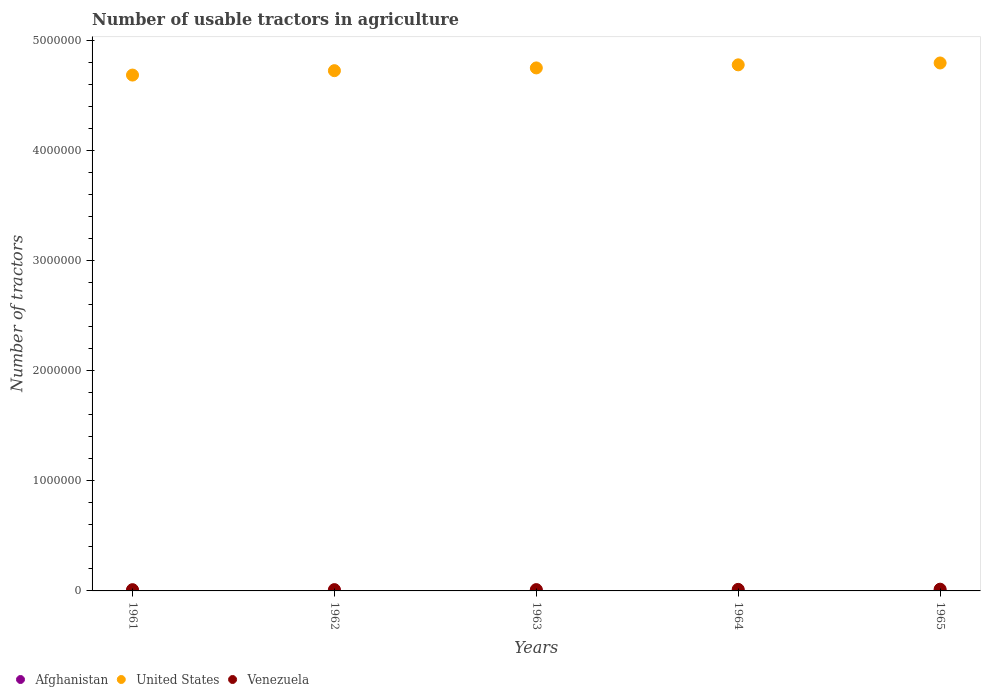How many different coloured dotlines are there?
Give a very brief answer. 3. Is the number of dotlines equal to the number of legend labels?
Give a very brief answer. Yes. What is the number of usable tractors in agriculture in Venezuela in 1965?
Give a very brief answer. 1.59e+04. Across all years, what is the maximum number of usable tractors in agriculture in Afghanistan?
Your answer should be compact. 300. Across all years, what is the minimum number of usable tractors in agriculture in Afghanistan?
Make the answer very short. 120. In which year was the number of usable tractors in agriculture in Afghanistan maximum?
Provide a short and direct response. 1965. In which year was the number of usable tractors in agriculture in Afghanistan minimum?
Ensure brevity in your answer.  1961. What is the total number of usable tractors in agriculture in United States in the graph?
Your response must be concise. 2.38e+07. What is the difference between the number of usable tractors in agriculture in Venezuela in 1962 and that in 1964?
Your answer should be compact. -2280. What is the difference between the number of usable tractors in agriculture in United States in 1965 and the number of usable tractors in agriculture in Afghanistan in 1963?
Ensure brevity in your answer.  4.80e+06. What is the average number of usable tractors in agriculture in United States per year?
Give a very brief answer. 4.75e+06. In the year 1965, what is the difference between the number of usable tractors in agriculture in Venezuela and number of usable tractors in agriculture in United States?
Provide a succinct answer. -4.78e+06. What is the ratio of the number of usable tractors in agriculture in Venezuela in 1962 to that in 1963?
Offer a very short reply. 0.99. Is the number of usable tractors in agriculture in Afghanistan in 1962 less than that in 1964?
Offer a terse response. Yes. What is the difference between the highest and the second highest number of usable tractors in agriculture in Venezuela?
Keep it short and to the point. 1720. What is the difference between the highest and the lowest number of usable tractors in agriculture in Venezuela?
Ensure brevity in your answer.  4500. In how many years, is the number of usable tractors in agriculture in Afghanistan greater than the average number of usable tractors in agriculture in Afghanistan taken over all years?
Keep it short and to the point. 3. Is it the case that in every year, the sum of the number of usable tractors in agriculture in Afghanistan and number of usable tractors in agriculture in Venezuela  is greater than the number of usable tractors in agriculture in United States?
Your answer should be compact. No. Is the number of usable tractors in agriculture in Afghanistan strictly greater than the number of usable tractors in agriculture in Venezuela over the years?
Offer a very short reply. No. How many years are there in the graph?
Make the answer very short. 5. Are the values on the major ticks of Y-axis written in scientific E-notation?
Offer a terse response. No. How are the legend labels stacked?
Offer a very short reply. Horizontal. What is the title of the graph?
Provide a short and direct response. Number of usable tractors in agriculture. What is the label or title of the Y-axis?
Your answer should be compact. Number of tractors. What is the Number of tractors of Afghanistan in 1961?
Keep it short and to the point. 120. What is the Number of tractors in United States in 1961?
Offer a terse response. 4.69e+06. What is the Number of tractors of Venezuela in 1961?
Ensure brevity in your answer.  1.14e+04. What is the Number of tractors in Afghanistan in 1962?
Your answer should be compact. 150. What is the Number of tractors of United States in 1962?
Make the answer very short. 4.73e+06. What is the Number of tractors of Venezuela in 1962?
Your response must be concise. 1.19e+04. What is the Number of tractors in Afghanistan in 1963?
Provide a short and direct response. 200. What is the Number of tractors in United States in 1963?
Offer a very short reply. 4.76e+06. What is the Number of tractors in Venezuela in 1963?
Provide a succinct answer. 1.20e+04. What is the Number of tractors of United States in 1964?
Your answer should be very brief. 4.78e+06. What is the Number of tractors in Venezuela in 1964?
Your response must be concise. 1.42e+04. What is the Number of tractors in Afghanistan in 1965?
Provide a succinct answer. 300. What is the Number of tractors in United States in 1965?
Provide a short and direct response. 4.80e+06. What is the Number of tractors of Venezuela in 1965?
Give a very brief answer. 1.59e+04. Across all years, what is the maximum Number of tractors in Afghanistan?
Give a very brief answer. 300. Across all years, what is the maximum Number of tractors of United States?
Ensure brevity in your answer.  4.80e+06. Across all years, what is the maximum Number of tractors of Venezuela?
Your response must be concise. 1.59e+04. Across all years, what is the minimum Number of tractors in Afghanistan?
Offer a terse response. 120. Across all years, what is the minimum Number of tractors of United States?
Make the answer very short. 4.69e+06. Across all years, what is the minimum Number of tractors in Venezuela?
Keep it short and to the point. 1.14e+04. What is the total Number of tractors in Afghanistan in the graph?
Offer a terse response. 970. What is the total Number of tractors of United States in the graph?
Ensure brevity in your answer.  2.38e+07. What is the total Number of tractors in Venezuela in the graph?
Your answer should be very brief. 6.54e+04. What is the difference between the Number of tractors of Venezuela in 1961 and that in 1962?
Provide a succinct answer. -500. What is the difference between the Number of tractors in Afghanistan in 1961 and that in 1963?
Keep it short and to the point. -80. What is the difference between the Number of tractors in United States in 1961 and that in 1963?
Keep it short and to the point. -6.50e+04. What is the difference between the Number of tractors in Venezuela in 1961 and that in 1963?
Keep it short and to the point. -650. What is the difference between the Number of tractors in Afghanistan in 1961 and that in 1964?
Your answer should be compact. -80. What is the difference between the Number of tractors in United States in 1961 and that in 1964?
Give a very brief answer. -9.30e+04. What is the difference between the Number of tractors of Venezuela in 1961 and that in 1964?
Your answer should be compact. -2780. What is the difference between the Number of tractors of Afghanistan in 1961 and that in 1965?
Your answer should be compact. -180. What is the difference between the Number of tractors of Venezuela in 1961 and that in 1965?
Your answer should be compact. -4500. What is the difference between the Number of tractors of Afghanistan in 1962 and that in 1963?
Ensure brevity in your answer.  -50. What is the difference between the Number of tractors in United States in 1962 and that in 1963?
Ensure brevity in your answer.  -2.50e+04. What is the difference between the Number of tractors of Venezuela in 1962 and that in 1963?
Provide a succinct answer. -150. What is the difference between the Number of tractors of Afghanistan in 1962 and that in 1964?
Make the answer very short. -50. What is the difference between the Number of tractors of United States in 1962 and that in 1964?
Provide a short and direct response. -5.30e+04. What is the difference between the Number of tractors in Venezuela in 1962 and that in 1964?
Your response must be concise. -2280. What is the difference between the Number of tractors of Afghanistan in 1962 and that in 1965?
Your answer should be compact. -150. What is the difference between the Number of tractors in United States in 1962 and that in 1965?
Provide a succinct answer. -7.00e+04. What is the difference between the Number of tractors of Venezuela in 1962 and that in 1965?
Offer a very short reply. -4000. What is the difference between the Number of tractors of United States in 1963 and that in 1964?
Your answer should be very brief. -2.80e+04. What is the difference between the Number of tractors in Venezuela in 1963 and that in 1964?
Provide a short and direct response. -2130. What is the difference between the Number of tractors in Afghanistan in 1963 and that in 1965?
Your answer should be very brief. -100. What is the difference between the Number of tractors of United States in 1963 and that in 1965?
Give a very brief answer. -4.50e+04. What is the difference between the Number of tractors in Venezuela in 1963 and that in 1965?
Provide a succinct answer. -3850. What is the difference between the Number of tractors of Afghanistan in 1964 and that in 1965?
Keep it short and to the point. -100. What is the difference between the Number of tractors in United States in 1964 and that in 1965?
Your answer should be very brief. -1.70e+04. What is the difference between the Number of tractors of Venezuela in 1964 and that in 1965?
Make the answer very short. -1720. What is the difference between the Number of tractors in Afghanistan in 1961 and the Number of tractors in United States in 1962?
Offer a very short reply. -4.73e+06. What is the difference between the Number of tractors in Afghanistan in 1961 and the Number of tractors in Venezuela in 1962?
Give a very brief answer. -1.18e+04. What is the difference between the Number of tractors in United States in 1961 and the Number of tractors in Venezuela in 1962?
Offer a very short reply. 4.68e+06. What is the difference between the Number of tractors of Afghanistan in 1961 and the Number of tractors of United States in 1963?
Provide a short and direct response. -4.75e+06. What is the difference between the Number of tractors in Afghanistan in 1961 and the Number of tractors in Venezuela in 1963?
Your answer should be very brief. -1.19e+04. What is the difference between the Number of tractors of United States in 1961 and the Number of tractors of Venezuela in 1963?
Provide a short and direct response. 4.68e+06. What is the difference between the Number of tractors of Afghanistan in 1961 and the Number of tractors of United States in 1964?
Ensure brevity in your answer.  -4.78e+06. What is the difference between the Number of tractors in Afghanistan in 1961 and the Number of tractors in Venezuela in 1964?
Offer a very short reply. -1.41e+04. What is the difference between the Number of tractors of United States in 1961 and the Number of tractors of Venezuela in 1964?
Your answer should be very brief. 4.68e+06. What is the difference between the Number of tractors of Afghanistan in 1961 and the Number of tractors of United States in 1965?
Ensure brevity in your answer.  -4.80e+06. What is the difference between the Number of tractors in Afghanistan in 1961 and the Number of tractors in Venezuela in 1965?
Provide a succinct answer. -1.58e+04. What is the difference between the Number of tractors in United States in 1961 and the Number of tractors in Venezuela in 1965?
Keep it short and to the point. 4.67e+06. What is the difference between the Number of tractors in Afghanistan in 1962 and the Number of tractors in United States in 1963?
Your response must be concise. -4.75e+06. What is the difference between the Number of tractors in Afghanistan in 1962 and the Number of tractors in Venezuela in 1963?
Provide a short and direct response. -1.19e+04. What is the difference between the Number of tractors in United States in 1962 and the Number of tractors in Venezuela in 1963?
Ensure brevity in your answer.  4.72e+06. What is the difference between the Number of tractors in Afghanistan in 1962 and the Number of tractors in United States in 1964?
Keep it short and to the point. -4.78e+06. What is the difference between the Number of tractors in Afghanistan in 1962 and the Number of tractors in Venezuela in 1964?
Keep it short and to the point. -1.40e+04. What is the difference between the Number of tractors of United States in 1962 and the Number of tractors of Venezuela in 1964?
Offer a very short reply. 4.72e+06. What is the difference between the Number of tractors of Afghanistan in 1962 and the Number of tractors of United States in 1965?
Offer a very short reply. -4.80e+06. What is the difference between the Number of tractors in Afghanistan in 1962 and the Number of tractors in Venezuela in 1965?
Ensure brevity in your answer.  -1.58e+04. What is the difference between the Number of tractors of United States in 1962 and the Number of tractors of Venezuela in 1965?
Keep it short and to the point. 4.71e+06. What is the difference between the Number of tractors of Afghanistan in 1963 and the Number of tractors of United States in 1964?
Keep it short and to the point. -4.78e+06. What is the difference between the Number of tractors in Afghanistan in 1963 and the Number of tractors in Venezuela in 1964?
Keep it short and to the point. -1.40e+04. What is the difference between the Number of tractors of United States in 1963 and the Number of tractors of Venezuela in 1964?
Offer a terse response. 4.74e+06. What is the difference between the Number of tractors of Afghanistan in 1963 and the Number of tractors of United States in 1965?
Offer a very short reply. -4.80e+06. What is the difference between the Number of tractors of Afghanistan in 1963 and the Number of tractors of Venezuela in 1965?
Your answer should be compact. -1.57e+04. What is the difference between the Number of tractors in United States in 1963 and the Number of tractors in Venezuela in 1965?
Your answer should be compact. 4.74e+06. What is the difference between the Number of tractors in Afghanistan in 1964 and the Number of tractors in United States in 1965?
Offer a terse response. -4.80e+06. What is the difference between the Number of tractors in Afghanistan in 1964 and the Number of tractors in Venezuela in 1965?
Your answer should be very brief. -1.57e+04. What is the difference between the Number of tractors in United States in 1964 and the Number of tractors in Venezuela in 1965?
Your answer should be compact. 4.77e+06. What is the average Number of tractors in Afghanistan per year?
Provide a short and direct response. 194. What is the average Number of tractors of United States per year?
Keep it short and to the point. 4.75e+06. What is the average Number of tractors in Venezuela per year?
Provide a short and direct response. 1.31e+04. In the year 1961, what is the difference between the Number of tractors in Afghanistan and Number of tractors in United States?
Give a very brief answer. -4.69e+06. In the year 1961, what is the difference between the Number of tractors in Afghanistan and Number of tractors in Venezuela?
Your response must be concise. -1.13e+04. In the year 1961, what is the difference between the Number of tractors of United States and Number of tractors of Venezuela?
Your response must be concise. 4.68e+06. In the year 1962, what is the difference between the Number of tractors of Afghanistan and Number of tractors of United States?
Your answer should be very brief. -4.73e+06. In the year 1962, what is the difference between the Number of tractors in Afghanistan and Number of tractors in Venezuela?
Provide a short and direct response. -1.18e+04. In the year 1962, what is the difference between the Number of tractors of United States and Number of tractors of Venezuela?
Give a very brief answer. 4.72e+06. In the year 1963, what is the difference between the Number of tractors in Afghanistan and Number of tractors in United States?
Your answer should be compact. -4.75e+06. In the year 1963, what is the difference between the Number of tractors of Afghanistan and Number of tractors of Venezuela?
Keep it short and to the point. -1.18e+04. In the year 1963, what is the difference between the Number of tractors of United States and Number of tractors of Venezuela?
Keep it short and to the point. 4.74e+06. In the year 1964, what is the difference between the Number of tractors of Afghanistan and Number of tractors of United States?
Your answer should be compact. -4.78e+06. In the year 1964, what is the difference between the Number of tractors of Afghanistan and Number of tractors of Venezuela?
Ensure brevity in your answer.  -1.40e+04. In the year 1964, what is the difference between the Number of tractors of United States and Number of tractors of Venezuela?
Provide a short and direct response. 4.77e+06. In the year 1965, what is the difference between the Number of tractors of Afghanistan and Number of tractors of United States?
Provide a succinct answer. -4.80e+06. In the year 1965, what is the difference between the Number of tractors in Afghanistan and Number of tractors in Venezuela?
Provide a short and direct response. -1.56e+04. In the year 1965, what is the difference between the Number of tractors in United States and Number of tractors in Venezuela?
Your response must be concise. 4.78e+06. What is the ratio of the Number of tractors in Afghanistan in 1961 to that in 1962?
Your answer should be very brief. 0.8. What is the ratio of the Number of tractors in United States in 1961 to that in 1962?
Provide a short and direct response. 0.99. What is the ratio of the Number of tractors in Venezuela in 1961 to that in 1962?
Your response must be concise. 0.96. What is the ratio of the Number of tractors of Afghanistan in 1961 to that in 1963?
Keep it short and to the point. 0.6. What is the ratio of the Number of tractors of United States in 1961 to that in 1963?
Offer a terse response. 0.99. What is the ratio of the Number of tractors of Venezuela in 1961 to that in 1963?
Ensure brevity in your answer.  0.95. What is the ratio of the Number of tractors of United States in 1961 to that in 1964?
Offer a terse response. 0.98. What is the ratio of the Number of tractors of Venezuela in 1961 to that in 1964?
Make the answer very short. 0.8. What is the ratio of the Number of tractors in Afghanistan in 1961 to that in 1965?
Your response must be concise. 0.4. What is the ratio of the Number of tractors in United States in 1961 to that in 1965?
Provide a succinct answer. 0.98. What is the ratio of the Number of tractors in Venezuela in 1961 to that in 1965?
Make the answer very short. 0.72. What is the ratio of the Number of tractors in United States in 1962 to that in 1963?
Provide a succinct answer. 0.99. What is the ratio of the Number of tractors in Venezuela in 1962 to that in 1963?
Offer a very short reply. 0.99. What is the ratio of the Number of tractors in United States in 1962 to that in 1964?
Ensure brevity in your answer.  0.99. What is the ratio of the Number of tractors in Venezuela in 1962 to that in 1964?
Give a very brief answer. 0.84. What is the ratio of the Number of tractors in Afghanistan in 1962 to that in 1965?
Your answer should be very brief. 0.5. What is the ratio of the Number of tractors of United States in 1962 to that in 1965?
Keep it short and to the point. 0.99. What is the ratio of the Number of tractors in Venezuela in 1962 to that in 1965?
Your response must be concise. 0.75. What is the ratio of the Number of tractors of Afghanistan in 1963 to that in 1964?
Offer a terse response. 1. What is the ratio of the Number of tractors of Venezuela in 1963 to that in 1964?
Your response must be concise. 0.85. What is the ratio of the Number of tractors of Afghanistan in 1963 to that in 1965?
Ensure brevity in your answer.  0.67. What is the ratio of the Number of tractors in United States in 1963 to that in 1965?
Your answer should be very brief. 0.99. What is the ratio of the Number of tractors of Venezuela in 1963 to that in 1965?
Keep it short and to the point. 0.76. What is the ratio of the Number of tractors in Afghanistan in 1964 to that in 1965?
Provide a succinct answer. 0.67. What is the ratio of the Number of tractors of United States in 1964 to that in 1965?
Give a very brief answer. 1. What is the ratio of the Number of tractors in Venezuela in 1964 to that in 1965?
Your answer should be very brief. 0.89. What is the difference between the highest and the second highest Number of tractors in United States?
Offer a terse response. 1.70e+04. What is the difference between the highest and the second highest Number of tractors of Venezuela?
Give a very brief answer. 1720. What is the difference between the highest and the lowest Number of tractors in Afghanistan?
Make the answer very short. 180. What is the difference between the highest and the lowest Number of tractors of Venezuela?
Provide a succinct answer. 4500. 